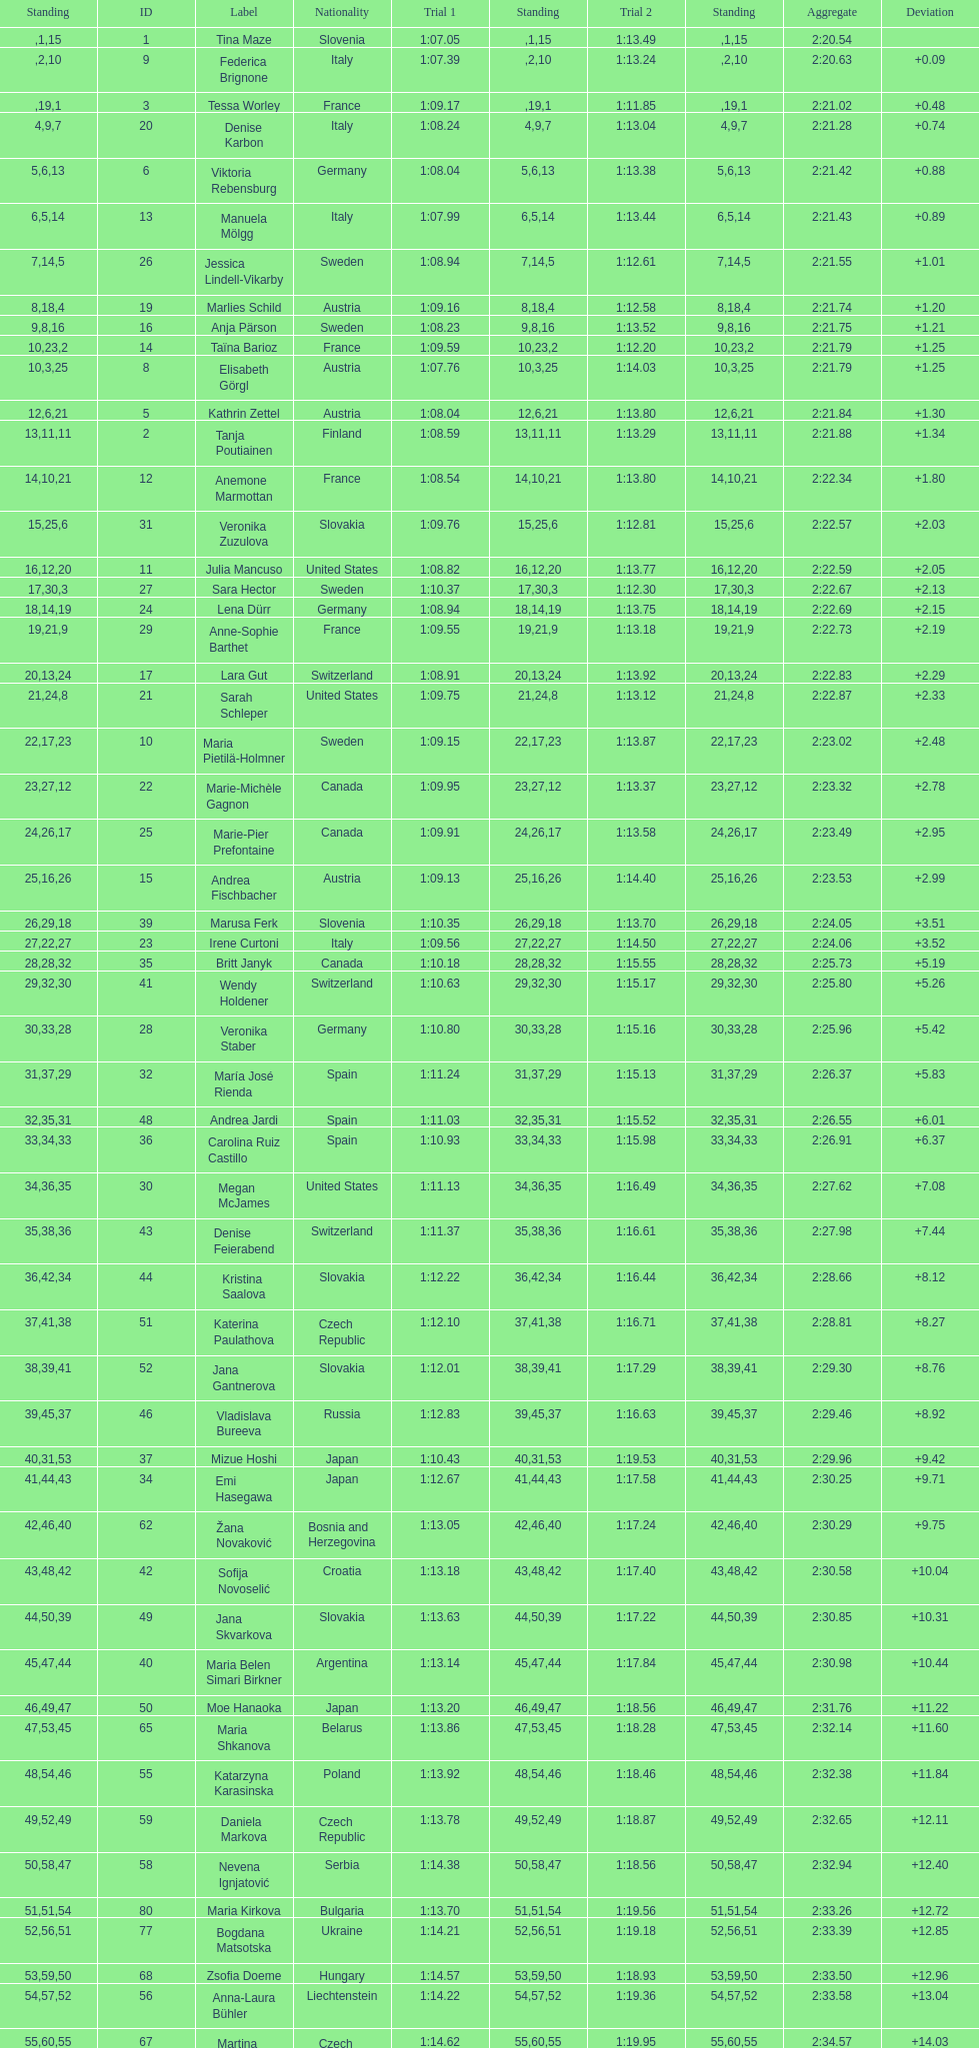How many total names are there? 116. 